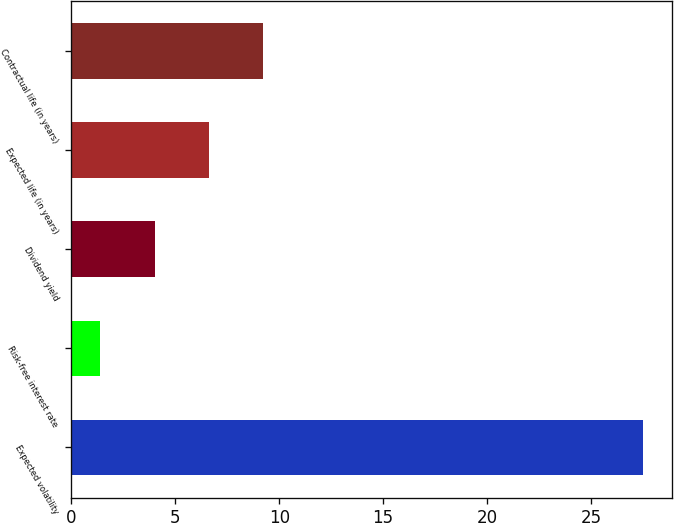Convert chart. <chart><loc_0><loc_0><loc_500><loc_500><bar_chart><fcel>Expected volatility<fcel>Risk-free interest rate<fcel>Dividend yield<fcel>Expected life (in years)<fcel>Contractual life (in years)<nl><fcel>27.5<fcel>1.4<fcel>4.01<fcel>6.62<fcel>9.23<nl></chart> 